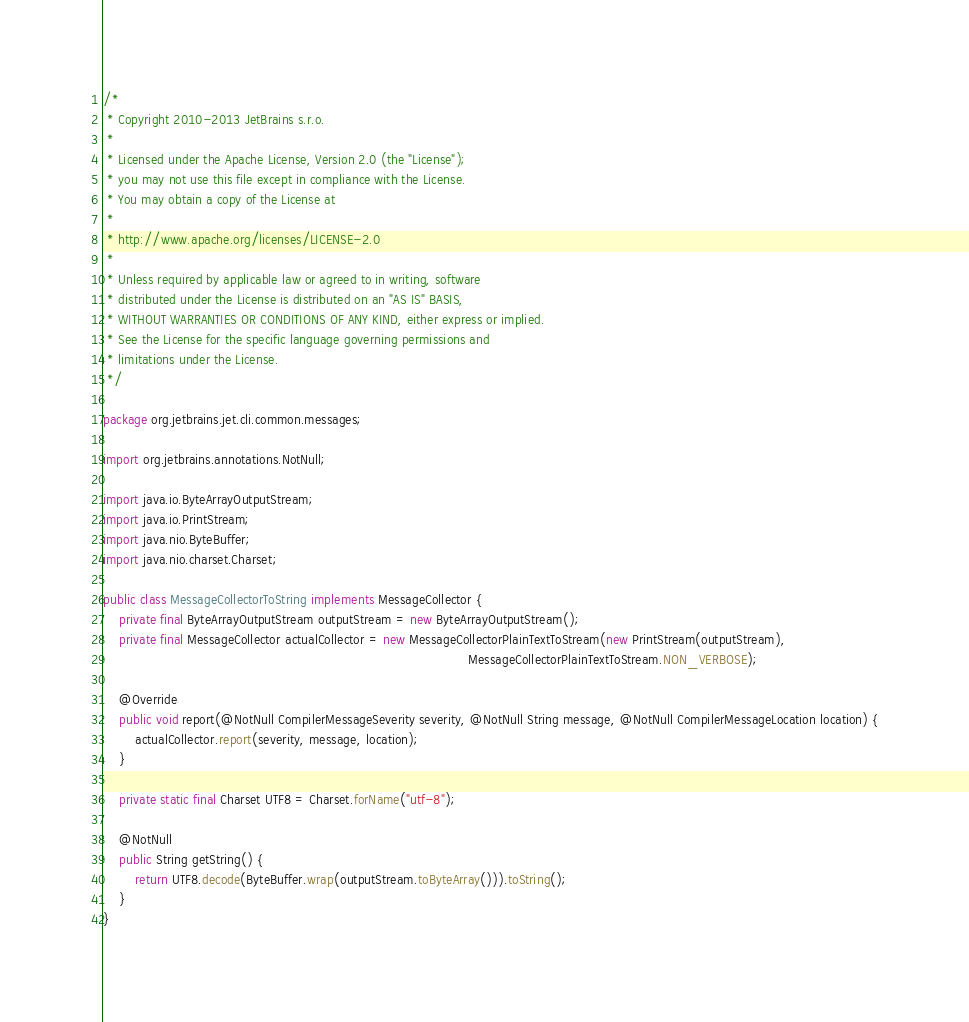<code> <loc_0><loc_0><loc_500><loc_500><_Java_>/*
 * Copyright 2010-2013 JetBrains s.r.o.
 *
 * Licensed under the Apache License, Version 2.0 (the "License");
 * you may not use this file except in compliance with the License.
 * You may obtain a copy of the License at
 *
 * http://www.apache.org/licenses/LICENSE-2.0
 *
 * Unless required by applicable law or agreed to in writing, software
 * distributed under the License is distributed on an "AS IS" BASIS,
 * WITHOUT WARRANTIES OR CONDITIONS OF ANY KIND, either express or implied.
 * See the License for the specific language governing permissions and
 * limitations under the License.
 */

package org.jetbrains.jet.cli.common.messages;

import org.jetbrains.annotations.NotNull;

import java.io.ByteArrayOutputStream;
import java.io.PrintStream;
import java.nio.ByteBuffer;
import java.nio.charset.Charset;

public class MessageCollectorToString implements MessageCollector {
    private final ByteArrayOutputStream outputStream = new ByteArrayOutputStream();
    private final MessageCollector actualCollector = new MessageCollectorPlainTextToStream(new PrintStream(outputStream),
                                                                                           MessageCollectorPlainTextToStream.NON_VERBOSE);

    @Override
    public void report(@NotNull CompilerMessageSeverity severity, @NotNull String message, @NotNull CompilerMessageLocation location) {
        actualCollector.report(severity, message, location);
    }

    private static final Charset UTF8 = Charset.forName("utf-8");

    @NotNull
    public String getString() {
        return UTF8.decode(ByteBuffer.wrap(outputStream.toByteArray())).toString();
    }
}
</code> 